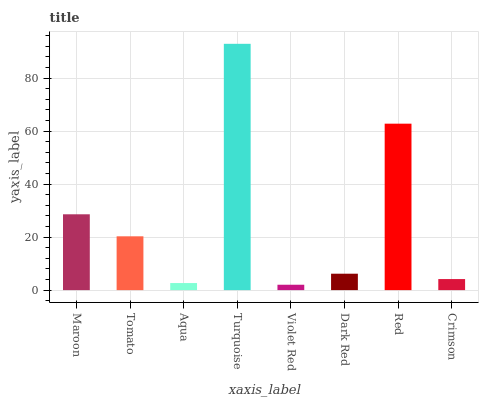Is Violet Red the minimum?
Answer yes or no. Yes. Is Turquoise the maximum?
Answer yes or no. Yes. Is Tomato the minimum?
Answer yes or no. No. Is Tomato the maximum?
Answer yes or no. No. Is Maroon greater than Tomato?
Answer yes or no. Yes. Is Tomato less than Maroon?
Answer yes or no. Yes. Is Tomato greater than Maroon?
Answer yes or no. No. Is Maroon less than Tomato?
Answer yes or no. No. Is Tomato the high median?
Answer yes or no. Yes. Is Dark Red the low median?
Answer yes or no. Yes. Is Crimson the high median?
Answer yes or no. No. Is Turquoise the low median?
Answer yes or no. No. 